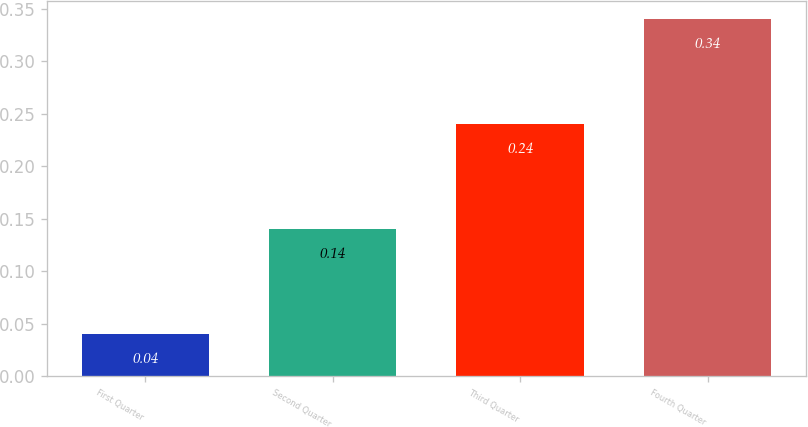<chart> <loc_0><loc_0><loc_500><loc_500><bar_chart><fcel>First Quarter<fcel>Second Quarter<fcel>Third Quarter<fcel>Fourth Quarter<nl><fcel>0.04<fcel>0.14<fcel>0.24<fcel>0.34<nl></chart> 